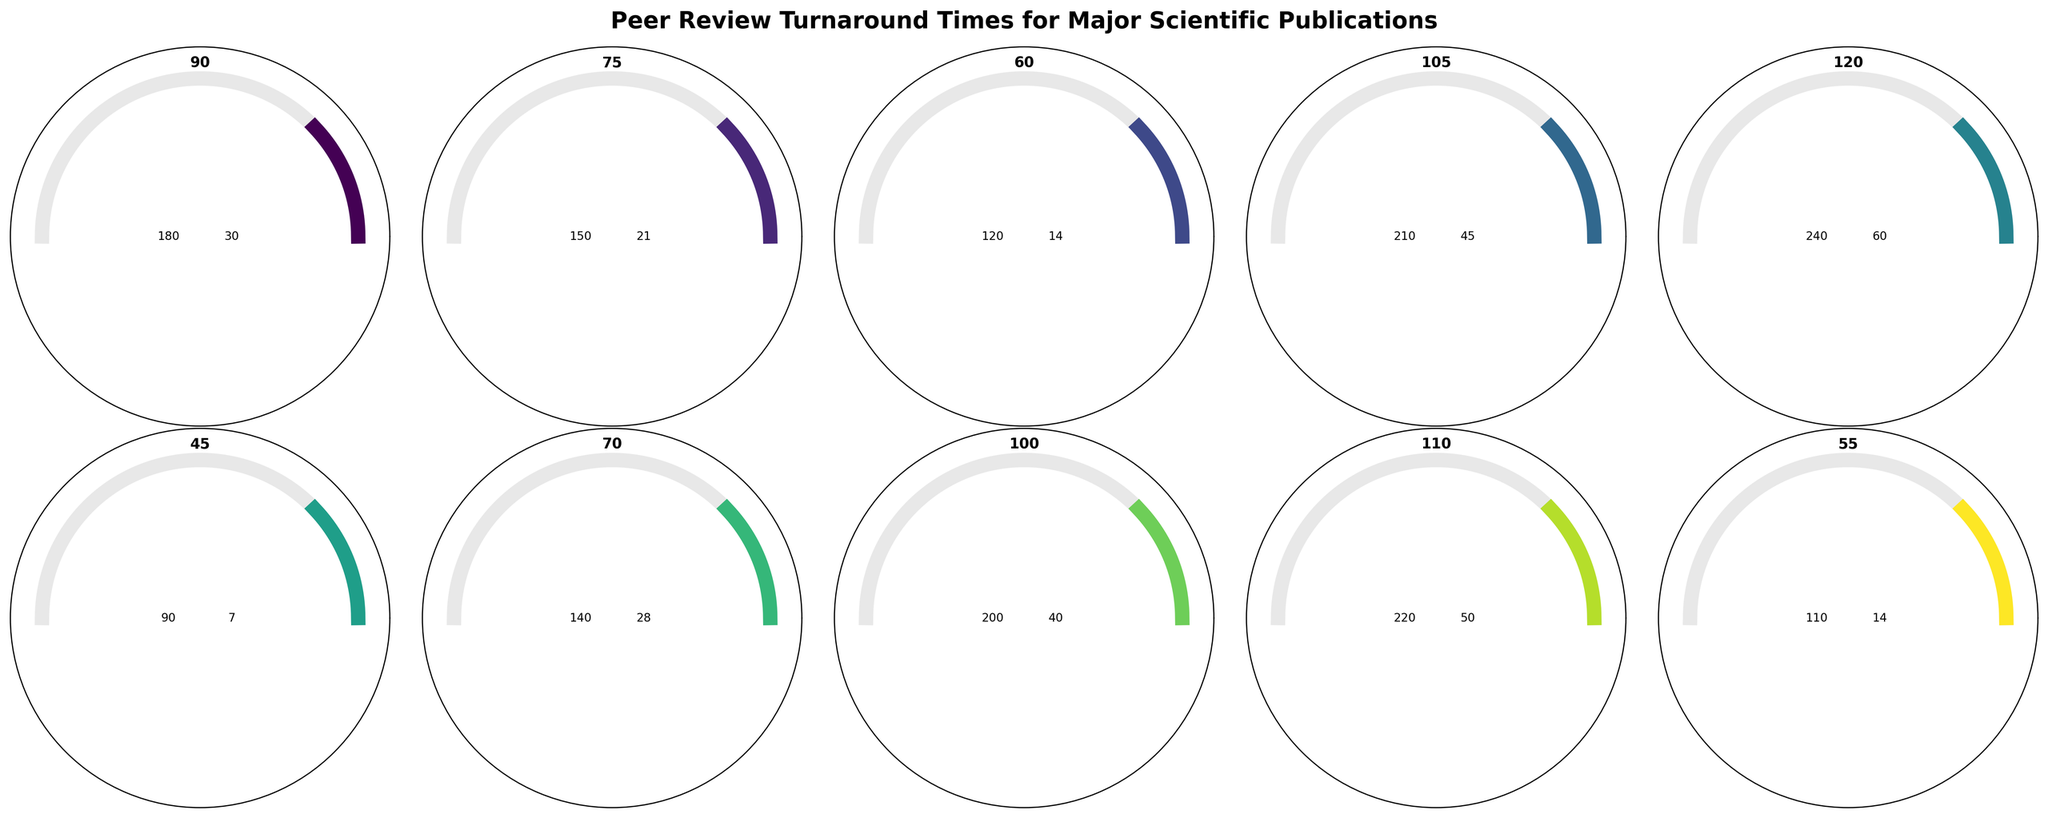What is the average turnaround time for PNAS? The value for the average turnaround time for PNAS is displayed prominently on the gauge chart labeled "PNAS." It is shown at the peak of the arc.
Answer: 60 days Which journal has the shortest minimum turnaround time? By observing the gauge charts, PLoS ONE has the smallest starting point on its gauge chart, indicated at "7" days.
Answer: PLoS ONE How does the maximum turnaround time for Cell compare to The Lancet? Look at the maximum values for both Cell and The Lancet on their respective gauge charts. The maximum for Cell is 210, while for The Lancet it is 240.
Answer: The Lancet has a higher maximum turnaround time than Cell Which journal has the longest average turnaround time? Look for the journal with the highest value at the middle of the gauge. The Lancet has the highest average turnaround time, indicated at 120 days.
Answer: The Lancet Is the average turnaround time for Nucleic Acids Research more than that of PLOS ONE? Check the middle values of both gauges. Nucleic Acids Research shows 55 days, while PLOS ONE shows 45 days.
Answer: Yes, the average turnaround time for Nucleic Acids Research is more than PLOS ONE What is the range of turnaround times for JAMA? The range is calculated by subtracting the minimum value from the maximum value. For JAMA, it is 200 - 40 = 160 days.
Answer: 160 days Which journal has a closer maximum turnaround time to Nature Communications? Find the journal with a maximum value closest to 140 days seen in Nature Communications. PNAS with 120 days is the closest.
Answer: PNAS What is the difference between the average turnaround times of the New England Journal of Medicine and Science? Subtract the average of Science (75 days) from New England Journal of Medicine (110 days). 110 - 75 = 35 days.
Answer: 35 days Are there any journals with a minimum turnaround time less than 20 days? Look for journals with the minimum values displayed closer to zero. PNAS (14 days) and Nucleic Acids Research (14 days) both meet this criterion.
Answer: Yes, PNAS and Nucleic Acids Research Which journal has an average turnaround time of around 70 days? Check the journals whose gauges show an average value nearest to 70 days. Nature Communications shows 70 days.
Answer: Nature Communications 